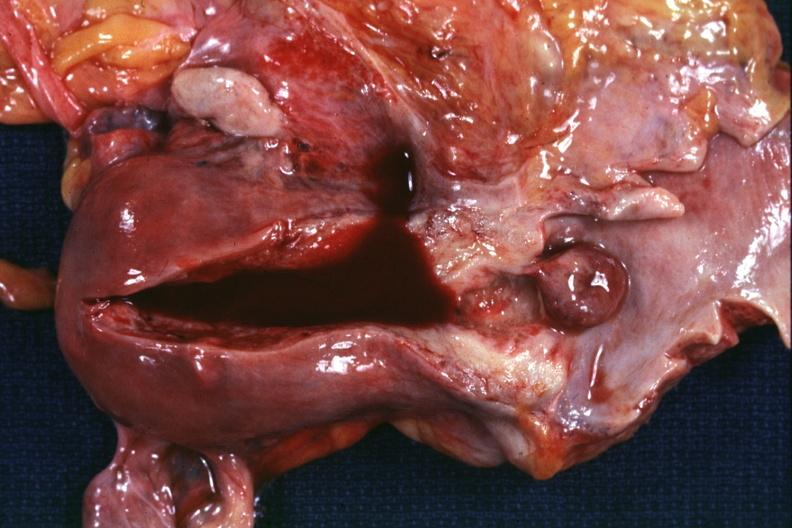does this image show opened uterus and vagina with pedunculated polyp extending from cervix into vagina 72yobf?
Answer the question using a single word or phrase. Yes 